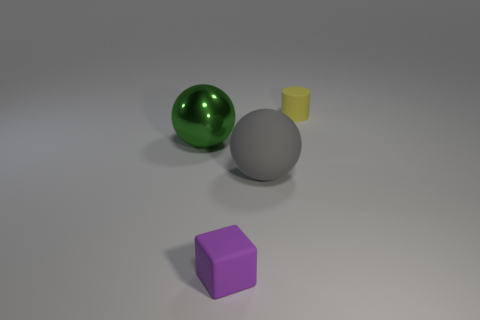Can you describe the colors of the objects visible in the image? Certainly! There are four distinct objects in the image, each with a different color. The large sphere is green with a reflective surface, the cube is matte purple, the sphere to the right of the cube is a non-reflective gray, and the small cylinder in front of the green sphere is yellow. 